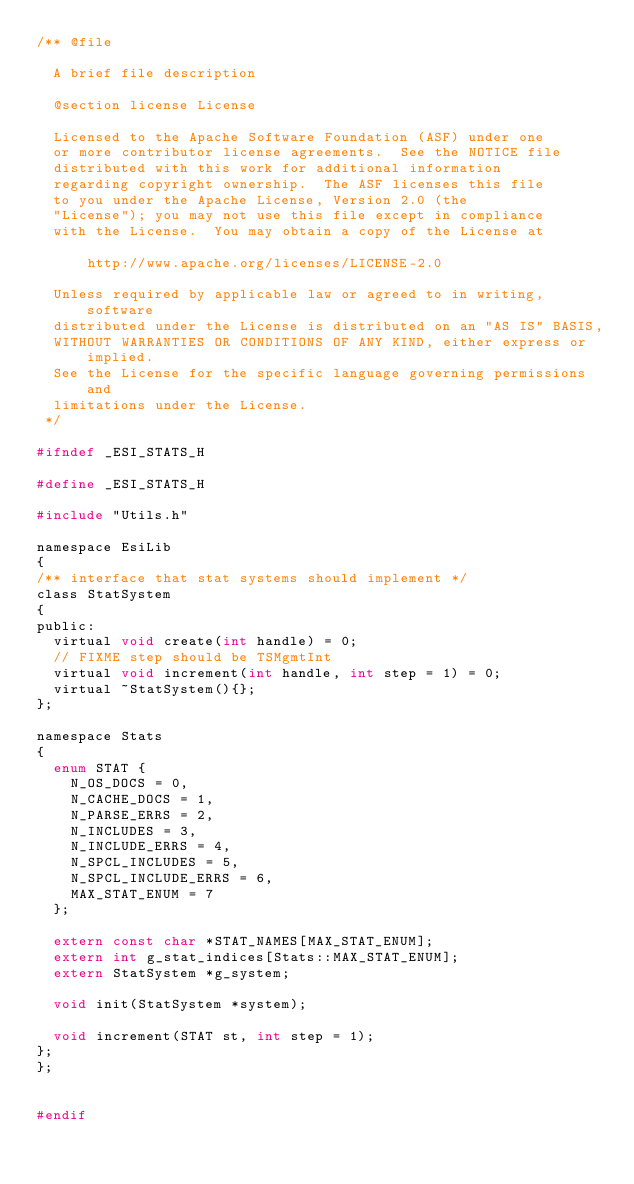Convert code to text. <code><loc_0><loc_0><loc_500><loc_500><_C_>/** @file

  A brief file description

  @section license License

  Licensed to the Apache Software Foundation (ASF) under one
  or more contributor license agreements.  See the NOTICE file
  distributed with this work for additional information
  regarding copyright ownership.  The ASF licenses this file
  to you under the Apache License, Version 2.0 (the
  "License"); you may not use this file except in compliance
  with the License.  You may obtain a copy of the License at

      http://www.apache.org/licenses/LICENSE-2.0

  Unless required by applicable law or agreed to in writing, software
  distributed under the License is distributed on an "AS IS" BASIS,
  WITHOUT WARRANTIES OR CONDITIONS OF ANY KIND, either express or implied.
  See the License for the specific language governing permissions and
  limitations under the License.
 */

#ifndef _ESI_STATS_H

#define _ESI_STATS_H

#include "Utils.h"

namespace EsiLib
{
/** interface that stat systems should implement */
class StatSystem
{
public:
  virtual void create(int handle) = 0;
  // FIXME step should be TSMgmtInt
  virtual void increment(int handle, int step = 1) = 0;
  virtual ~StatSystem(){};
};

namespace Stats
{
  enum STAT {
    N_OS_DOCS = 0,
    N_CACHE_DOCS = 1,
    N_PARSE_ERRS = 2,
    N_INCLUDES = 3,
    N_INCLUDE_ERRS = 4,
    N_SPCL_INCLUDES = 5,
    N_SPCL_INCLUDE_ERRS = 6,
    MAX_STAT_ENUM = 7
  };

  extern const char *STAT_NAMES[MAX_STAT_ENUM];
  extern int g_stat_indices[Stats::MAX_STAT_ENUM];
  extern StatSystem *g_system;

  void init(StatSystem *system);

  void increment(STAT st, int step = 1);
};
};


#endif
</code> 